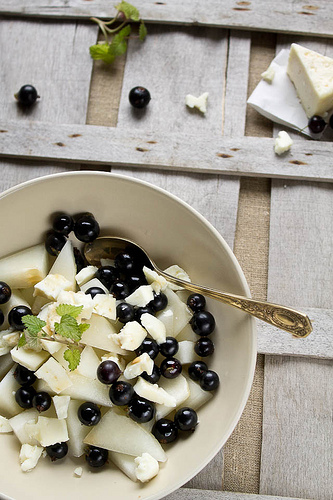<image>
Is there a spoon next to the bowl? No. The spoon is not positioned next to the bowl. They are located in different areas of the scene. 